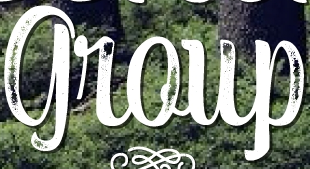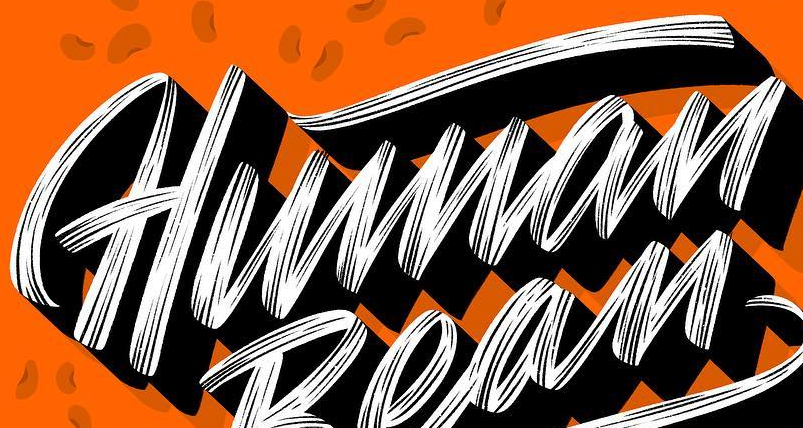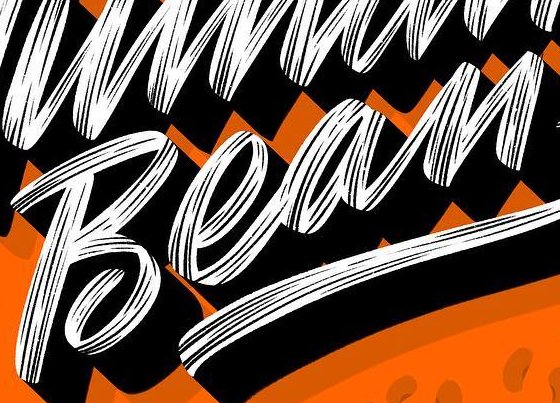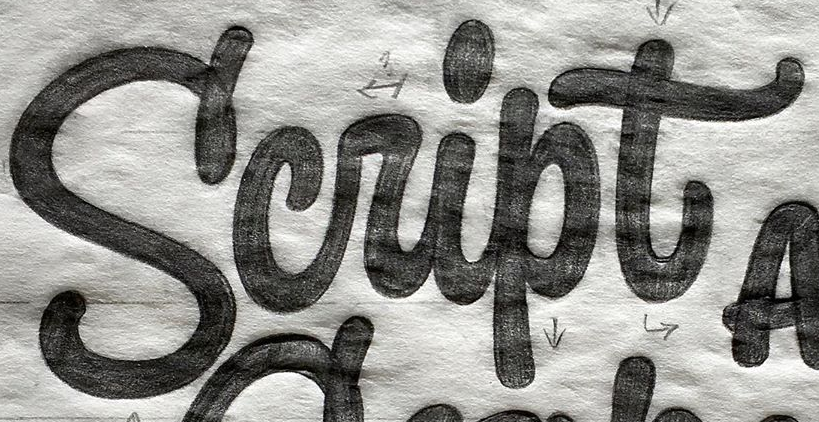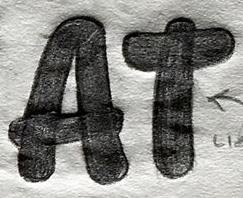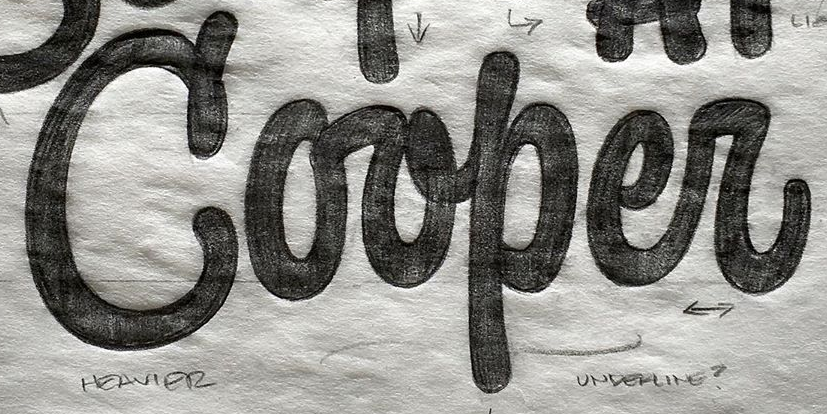Identify the words shown in these images in order, separated by a semicolon. group; Human; Bean; Script; AT; Corper 